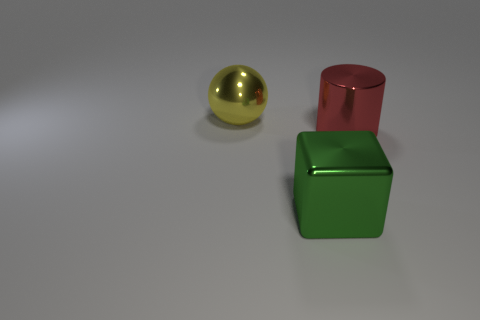Add 2 green objects. How many objects exist? 5 Subtract all blocks. How many objects are left? 2 Add 3 red objects. How many red objects exist? 4 Subtract 1 red cylinders. How many objects are left? 2 Subtract all large green cylinders. Subtract all yellow balls. How many objects are left? 2 Add 2 large green metallic things. How many large green metallic things are left? 3 